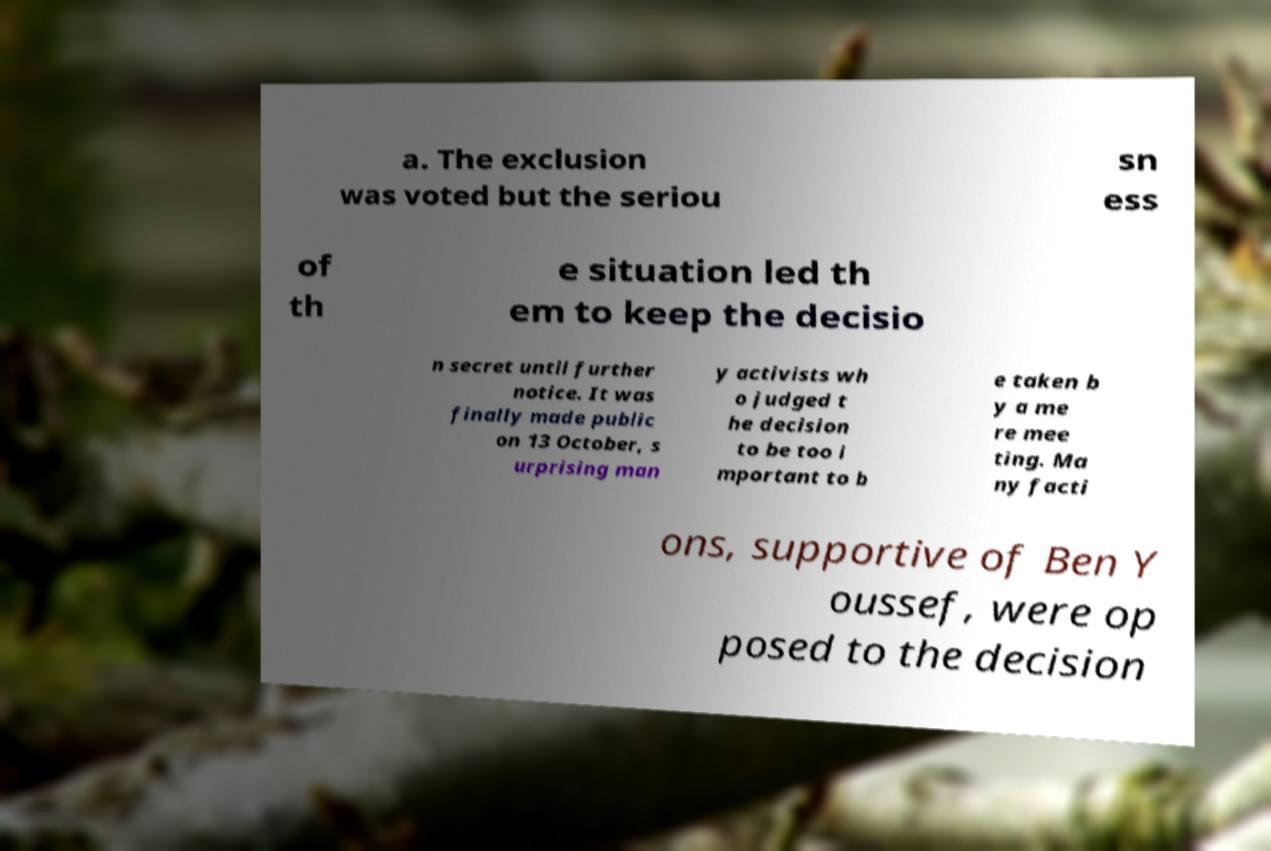Could you assist in decoding the text presented in this image and type it out clearly? a. The exclusion was voted but the seriou sn ess of th e situation led th em to keep the decisio n secret until further notice. It was finally made public on 13 October, s urprising man y activists wh o judged t he decision to be too i mportant to b e taken b y a me re mee ting. Ma ny facti ons, supportive of Ben Y oussef, were op posed to the decision 